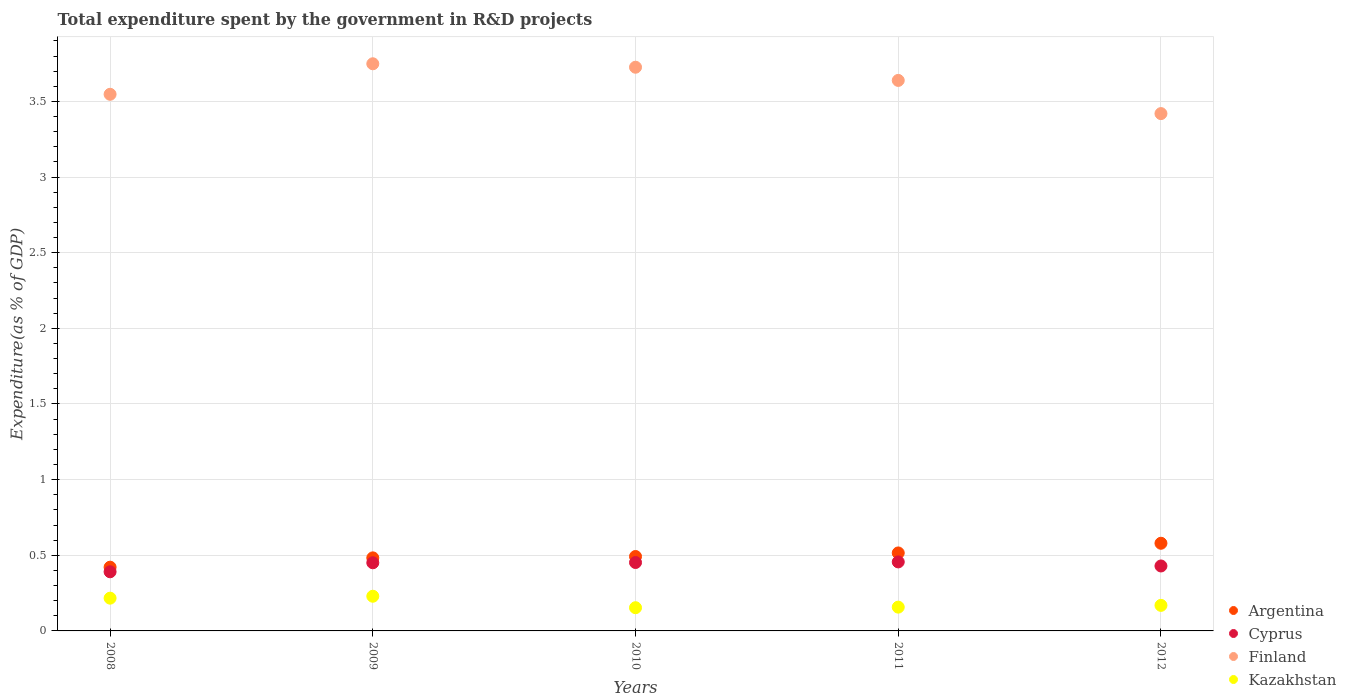Is the number of dotlines equal to the number of legend labels?
Your response must be concise. Yes. What is the total expenditure spent by the government in R&D projects in Cyprus in 2010?
Give a very brief answer. 0.45. Across all years, what is the maximum total expenditure spent by the government in R&D projects in Argentina?
Your response must be concise. 0.58. Across all years, what is the minimum total expenditure spent by the government in R&D projects in Kazakhstan?
Offer a terse response. 0.15. In which year was the total expenditure spent by the government in R&D projects in Argentina maximum?
Ensure brevity in your answer.  2012. What is the total total expenditure spent by the government in R&D projects in Kazakhstan in the graph?
Keep it short and to the point. 0.93. What is the difference between the total expenditure spent by the government in R&D projects in Kazakhstan in 2010 and that in 2011?
Offer a very short reply. -0. What is the difference between the total expenditure spent by the government in R&D projects in Argentina in 2008 and the total expenditure spent by the government in R&D projects in Cyprus in 2012?
Offer a very short reply. -0.01. What is the average total expenditure spent by the government in R&D projects in Argentina per year?
Keep it short and to the point. 0.5. In the year 2008, what is the difference between the total expenditure spent by the government in R&D projects in Argentina and total expenditure spent by the government in R&D projects in Cyprus?
Offer a terse response. 0.03. What is the ratio of the total expenditure spent by the government in R&D projects in Finland in 2008 to that in 2011?
Provide a short and direct response. 0.97. Is the total expenditure spent by the government in R&D projects in Argentina in 2011 less than that in 2012?
Your answer should be very brief. Yes. What is the difference between the highest and the second highest total expenditure spent by the government in R&D projects in Cyprus?
Keep it short and to the point. 0. What is the difference between the highest and the lowest total expenditure spent by the government in R&D projects in Argentina?
Your answer should be compact. 0.16. In how many years, is the total expenditure spent by the government in R&D projects in Argentina greater than the average total expenditure spent by the government in R&D projects in Argentina taken over all years?
Your response must be concise. 2. Is the total expenditure spent by the government in R&D projects in Kazakhstan strictly greater than the total expenditure spent by the government in R&D projects in Cyprus over the years?
Provide a short and direct response. No. Is the total expenditure spent by the government in R&D projects in Cyprus strictly less than the total expenditure spent by the government in R&D projects in Finland over the years?
Keep it short and to the point. Yes. How many years are there in the graph?
Offer a very short reply. 5. Are the values on the major ticks of Y-axis written in scientific E-notation?
Your response must be concise. No. Does the graph contain any zero values?
Make the answer very short. No. Does the graph contain grids?
Offer a terse response. Yes. What is the title of the graph?
Your answer should be compact. Total expenditure spent by the government in R&D projects. Does "United Arab Emirates" appear as one of the legend labels in the graph?
Keep it short and to the point. No. What is the label or title of the X-axis?
Give a very brief answer. Years. What is the label or title of the Y-axis?
Make the answer very short. Expenditure(as % of GDP). What is the Expenditure(as % of GDP) in Argentina in 2008?
Provide a succinct answer. 0.42. What is the Expenditure(as % of GDP) of Cyprus in 2008?
Keep it short and to the point. 0.39. What is the Expenditure(as % of GDP) of Finland in 2008?
Your answer should be compact. 3.55. What is the Expenditure(as % of GDP) of Kazakhstan in 2008?
Make the answer very short. 0.22. What is the Expenditure(as % of GDP) of Argentina in 2009?
Provide a short and direct response. 0.48. What is the Expenditure(as % of GDP) in Cyprus in 2009?
Your response must be concise. 0.45. What is the Expenditure(as % of GDP) in Finland in 2009?
Your response must be concise. 3.75. What is the Expenditure(as % of GDP) of Kazakhstan in 2009?
Provide a short and direct response. 0.23. What is the Expenditure(as % of GDP) in Argentina in 2010?
Your response must be concise. 0.49. What is the Expenditure(as % of GDP) of Cyprus in 2010?
Offer a very short reply. 0.45. What is the Expenditure(as % of GDP) of Finland in 2010?
Keep it short and to the point. 3.73. What is the Expenditure(as % of GDP) in Kazakhstan in 2010?
Give a very brief answer. 0.15. What is the Expenditure(as % of GDP) in Argentina in 2011?
Provide a short and direct response. 0.52. What is the Expenditure(as % of GDP) of Cyprus in 2011?
Your answer should be compact. 0.46. What is the Expenditure(as % of GDP) of Finland in 2011?
Ensure brevity in your answer.  3.64. What is the Expenditure(as % of GDP) in Kazakhstan in 2011?
Provide a succinct answer. 0.16. What is the Expenditure(as % of GDP) in Argentina in 2012?
Your answer should be compact. 0.58. What is the Expenditure(as % of GDP) in Cyprus in 2012?
Provide a succinct answer. 0.43. What is the Expenditure(as % of GDP) of Finland in 2012?
Offer a terse response. 3.42. What is the Expenditure(as % of GDP) in Kazakhstan in 2012?
Provide a short and direct response. 0.17. Across all years, what is the maximum Expenditure(as % of GDP) in Argentina?
Your answer should be very brief. 0.58. Across all years, what is the maximum Expenditure(as % of GDP) of Cyprus?
Offer a terse response. 0.46. Across all years, what is the maximum Expenditure(as % of GDP) of Finland?
Provide a short and direct response. 3.75. Across all years, what is the maximum Expenditure(as % of GDP) in Kazakhstan?
Offer a terse response. 0.23. Across all years, what is the minimum Expenditure(as % of GDP) in Argentina?
Make the answer very short. 0.42. Across all years, what is the minimum Expenditure(as % of GDP) in Cyprus?
Provide a short and direct response. 0.39. Across all years, what is the minimum Expenditure(as % of GDP) of Finland?
Keep it short and to the point. 3.42. Across all years, what is the minimum Expenditure(as % of GDP) in Kazakhstan?
Offer a very short reply. 0.15. What is the total Expenditure(as % of GDP) of Argentina in the graph?
Make the answer very short. 2.49. What is the total Expenditure(as % of GDP) in Cyprus in the graph?
Your answer should be compact. 2.18. What is the total Expenditure(as % of GDP) in Finland in the graph?
Offer a terse response. 18.08. What is the total Expenditure(as % of GDP) in Kazakhstan in the graph?
Provide a short and direct response. 0.93. What is the difference between the Expenditure(as % of GDP) in Argentina in 2008 and that in 2009?
Ensure brevity in your answer.  -0.06. What is the difference between the Expenditure(as % of GDP) of Cyprus in 2008 and that in 2009?
Give a very brief answer. -0.06. What is the difference between the Expenditure(as % of GDP) in Finland in 2008 and that in 2009?
Offer a terse response. -0.2. What is the difference between the Expenditure(as % of GDP) in Kazakhstan in 2008 and that in 2009?
Your answer should be compact. -0.01. What is the difference between the Expenditure(as % of GDP) of Argentina in 2008 and that in 2010?
Offer a very short reply. -0.07. What is the difference between the Expenditure(as % of GDP) of Cyprus in 2008 and that in 2010?
Keep it short and to the point. -0.06. What is the difference between the Expenditure(as % of GDP) in Finland in 2008 and that in 2010?
Your answer should be compact. -0.18. What is the difference between the Expenditure(as % of GDP) in Kazakhstan in 2008 and that in 2010?
Your answer should be compact. 0.06. What is the difference between the Expenditure(as % of GDP) in Argentina in 2008 and that in 2011?
Provide a short and direct response. -0.09. What is the difference between the Expenditure(as % of GDP) of Cyprus in 2008 and that in 2011?
Provide a succinct answer. -0.07. What is the difference between the Expenditure(as % of GDP) of Finland in 2008 and that in 2011?
Keep it short and to the point. -0.09. What is the difference between the Expenditure(as % of GDP) in Kazakhstan in 2008 and that in 2011?
Your answer should be compact. 0.06. What is the difference between the Expenditure(as % of GDP) of Argentina in 2008 and that in 2012?
Offer a very short reply. -0.16. What is the difference between the Expenditure(as % of GDP) of Cyprus in 2008 and that in 2012?
Offer a very short reply. -0.04. What is the difference between the Expenditure(as % of GDP) of Finland in 2008 and that in 2012?
Make the answer very short. 0.13. What is the difference between the Expenditure(as % of GDP) of Kazakhstan in 2008 and that in 2012?
Give a very brief answer. 0.05. What is the difference between the Expenditure(as % of GDP) of Argentina in 2009 and that in 2010?
Offer a very short reply. -0.01. What is the difference between the Expenditure(as % of GDP) in Cyprus in 2009 and that in 2010?
Ensure brevity in your answer.  -0. What is the difference between the Expenditure(as % of GDP) in Finland in 2009 and that in 2010?
Keep it short and to the point. 0.02. What is the difference between the Expenditure(as % of GDP) of Kazakhstan in 2009 and that in 2010?
Your answer should be very brief. 0.08. What is the difference between the Expenditure(as % of GDP) in Argentina in 2009 and that in 2011?
Ensure brevity in your answer.  -0.03. What is the difference between the Expenditure(as % of GDP) in Cyprus in 2009 and that in 2011?
Your answer should be very brief. -0.01. What is the difference between the Expenditure(as % of GDP) of Finland in 2009 and that in 2011?
Provide a short and direct response. 0.11. What is the difference between the Expenditure(as % of GDP) in Kazakhstan in 2009 and that in 2011?
Keep it short and to the point. 0.07. What is the difference between the Expenditure(as % of GDP) of Argentina in 2009 and that in 2012?
Your answer should be compact. -0.1. What is the difference between the Expenditure(as % of GDP) in Cyprus in 2009 and that in 2012?
Keep it short and to the point. 0.02. What is the difference between the Expenditure(as % of GDP) of Finland in 2009 and that in 2012?
Make the answer very short. 0.33. What is the difference between the Expenditure(as % of GDP) in Kazakhstan in 2009 and that in 2012?
Provide a succinct answer. 0.06. What is the difference between the Expenditure(as % of GDP) of Argentina in 2010 and that in 2011?
Offer a terse response. -0.02. What is the difference between the Expenditure(as % of GDP) of Cyprus in 2010 and that in 2011?
Your answer should be very brief. -0. What is the difference between the Expenditure(as % of GDP) of Finland in 2010 and that in 2011?
Provide a succinct answer. 0.09. What is the difference between the Expenditure(as % of GDP) of Kazakhstan in 2010 and that in 2011?
Your answer should be compact. -0. What is the difference between the Expenditure(as % of GDP) in Argentina in 2010 and that in 2012?
Provide a short and direct response. -0.09. What is the difference between the Expenditure(as % of GDP) in Cyprus in 2010 and that in 2012?
Offer a very short reply. 0.02. What is the difference between the Expenditure(as % of GDP) of Finland in 2010 and that in 2012?
Your answer should be very brief. 0.31. What is the difference between the Expenditure(as % of GDP) of Kazakhstan in 2010 and that in 2012?
Keep it short and to the point. -0.02. What is the difference between the Expenditure(as % of GDP) in Argentina in 2011 and that in 2012?
Ensure brevity in your answer.  -0.06. What is the difference between the Expenditure(as % of GDP) of Cyprus in 2011 and that in 2012?
Your answer should be very brief. 0.03. What is the difference between the Expenditure(as % of GDP) of Finland in 2011 and that in 2012?
Make the answer very short. 0.22. What is the difference between the Expenditure(as % of GDP) of Kazakhstan in 2011 and that in 2012?
Provide a succinct answer. -0.01. What is the difference between the Expenditure(as % of GDP) of Argentina in 2008 and the Expenditure(as % of GDP) of Cyprus in 2009?
Your answer should be compact. -0.03. What is the difference between the Expenditure(as % of GDP) of Argentina in 2008 and the Expenditure(as % of GDP) of Finland in 2009?
Your response must be concise. -3.33. What is the difference between the Expenditure(as % of GDP) in Argentina in 2008 and the Expenditure(as % of GDP) in Kazakhstan in 2009?
Give a very brief answer. 0.19. What is the difference between the Expenditure(as % of GDP) of Cyprus in 2008 and the Expenditure(as % of GDP) of Finland in 2009?
Offer a very short reply. -3.36. What is the difference between the Expenditure(as % of GDP) of Cyprus in 2008 and the Expenditure(as % of GDP) of Kazakhstan in 2009?
Give a very brief answer. 0.16. What is the difference between the Expenditure(as % of GDP) in Finland in 2008 and the Expenditure(as % of GDP) in Kazakhstan in 2009?
Your answer should be compact. 3.32. What is the difference between the Expenditure(as % of GDP) in Argentina in 2008 and the Expenditure(as % of GDP) in Cyprus in 2010?
Provide a short and direct response. -0.03. What is the difference between the Expenditure(as % of GDP) in Argentina in 2008 and the Expenditure(as % of GDP) in Finland in 2010?
Your response must be concise. -3.3. What is the difference between the Expenditure(as % of GDP) in Argentina in 2008 and the Expenditure(as % of GDP) in Kazakhstan in 2010?
Keep it short and to the point. 0.27. What is the difference between the Expenditure(as % of GDP) in Cyprus in 2008 and the Expenditure(as % of GDP) in Finland in 2010?
Your answer should be compact. -3.34. What is the difference between the Expenditure(as % of GDP) in Cyprus in 2008 and the Expenditure(as % of GDP) in Kazakhstan in 2010?
Your response must be concise. 0.24. What is the difference between the Expenditure(as % of GDP) in Finland in 2008 and the Expenditure(as % of GDP) in Kazakhstan in 2010?
Offer a very short reply. 3.39. What is the difference between the Expenditure(as % of GDP) in Argentina in 2008 and the Expenditure(as % of GDP) in Cyprus in 2011?
Your answer should be very brief. -0.03. What is the difference between the Expenditure(as % of GDP) of Argentina in 2008 and the Expenditure(as % of GDP) of Finland in 2011?
Your answer should be very brief. -3.22. What is the difference between the Expenditure(as % of GDP) in Argentina in 2008 and the Expenditure(as % of GDP) in Kazakhstan in 2011?
Provide a succinct answer. 0.26. What is the difference between the Expenditure(as % of GDP) in Cyprus in 2008 and the Expenditure(as % of GDP) in Finland in 2011?
Your response must be concise. -3.25. What is the difference between the Expenditure(as % of GDP) in Cyprus in 2008 and the Expenditure(as % of GDP) in Kazakhstan in 2011?
Your response must be concise. 0.23. What is the difference between the Expenditure(as % of GDP) of Finland in 2008 and the Expenditure(as % of GDP) of Kazakhstan in 2011?
Your answer should be compact. 3.39. What is the difference between the Expenditure(as % of GDP) of Argentina in 2008 and the Expenditure(as % of GDP) of Cyprus in 2012?
Offer a terse response. -0.01. What is the difference between the Expenditure(as % of GDP) in Argentina in 2008 and the Expenditure(as % of GDP) in Finland in 2012?
Your response must be concise. -3. What is the difference between the Expenditure(as % of GDP) of Argentina in 2008 and the Expenditure(as % of GDP) of Kazakhstan in 2012?
Your answer should be compact. 0.25. What is the difference between the Expenditure(as % of GDP) of Cyprus in 2008 and the Expenditure(as % of GDP) of Finland in 2012?
Your answer should be very brief. -3.03. What is the difference between the Expenditure(as % of GDP) of Cyprus in 2008 and the Expenditure(as % of GDP) of Kazakhstan in 2012?
Your answer should be compact. 0.22. What is the difference between the Expenditure(as % of GDP) in Finland in 2008 and the Expenditure(as % of GDP) in Kazakhstan in 2012?
Your answer should be very brief. 3.38. What is the difference between the Expenditure(as % of GDP) in Argentina in 2009 and the Expenditure(as % of GDP) in Cyprus in 2010?
Provide a short and direct response. 0.03. What is the difference between the Expenditure(as % of GDP) of Argentina in 2009 and the Expenditure(as % of GDP) of Finland in 2010?
Offer a terse response. -3.24. What is the difference between the Expenditure(as % of GDP) of Argentina in 2009 and the Expenditure(as % of GDP) of Kazakhstan in 2010?
Your response must be concise. 0.33. What is the difference between the Expenditure(as % of GDP) in Cyprus in 2009 and the Expenditure(as % of GDP) in Finland in 2010?
Your response must be concise. -3.28. What is the difference between the Expenditure(as % of GDP) of Cyprus in 2009 and the Expenditure(as % of GDP) of Kazakhstan in 2010?
Your response must be concise. 0.3. What is the difference between the Expenditure(as % of GDP) of Finland in 2009 and the Expenditure(as % of GDP) of Kazakhstan in 2010?
Keep it short and to the point. 3.6. What is the difference between the Expenditure(as % of GDP) in Argentina in 2009 and the Expenditure(as % of GDP) in Cyprus in 2011?
Your answer should be very brief. 0.03. What is the difference between the Expenditure(as % of GDP) in Argentina in 2009 and the Expenditure(as % of GDP) in Finland in 2011?
Your answer should be compact. -3.16. What is the difference between the Expenditure(as % of GDP) of Argentina in 2009 and the Expenditure(as % of GDP) of Kazakhstan in 2011?
Provide a short and direct response. 0.33. What is the difference between the Expenditure(as % of GDP) of Cyprus in 2009 and the Expenditure(as % of GDP) of Finland in 2011?
Offer a very short reply. -3.19. What is the difference between the Expenditure(as % of GDP) of Cyprus in 2009 and the Expenditure(as % of GDP) of Kazakhstan in 2011?
Provide a succinct answer. 0.29. What is the difference between the Expenditure(as % of GDP) of Finland in 2009 and the Expenditure(as % of GDP) of Kazakhstan in 2011?
Ensure brevity in your answer.  3.59. What is the difference between the Expenditure(as % of GDP) in Argentina in 2009 and the Expenditure(as % of GDP) in Cyprus in 2012?
Keep it short and to the point. 0.05. What is the difference between the Expenditure(as % of GDP) of Argentina in 2009 and the Expenditure(as % of GDP) of Finland in 2012?
Offer a terse response. -2.94. What is the difference between the Expenditure(as % of GDP) in Argentina in 2009 and the Expenditure(as % of GDP) in Kazakhstan in 2012?
Provide a short and direct response. 0.31. What is the difference between the Expenditure(as % of GDP) in Cyprus in 2009 and the Expenditure(as % of GDP) in Finland in 2012?
Make the answer very short. -2.97. What is the difference between the Expenditure(as % of GDP) of Cyprus in 2009 and the Expenditure(as % of GDP) of Kazakhstan in 2012?
Offer a very short reply. 0.28. What is the difference between the Expenditure(as % of GDP) of Finland in 2009 and the Expenditure(as % of GDP) of Kazakhstan in 2012?
Provide a succinct answer. 3.58. What is the difference between the Expenditure(as % of GDP) in Argentina in 2010 and the Expenditure(as % of GDP) in Cyprus in 2011?
Offer a terse response. 0.04. What is the difference between the Expenditure(as % of GDP) of Argentina in 2010 and the Expenditure(as % of GDP) of Finland in 2011?
Keep it short and to the point. -3.15. What is the difference between the Expenditure(as % of GDP) in Argentina in 2010 and the Expenditure(as % of GDP) in Kazakhstan in 2011?
Keep it short and to the point. 0.33. What is the difference between the Expenditure(as % of GDP) of Cyprus in 2010 and the Expenditure(as % of GDP) of Finland in 2011?
Your answer should be very brief. -3.19. What is the difference between the Expenditure(as % of GDP) of Cyprus in 2010 and the Expenditure(as % of GDP) of Kazakhstan in 2011?
Offer a terse response. 0.29. What is the difference between the Expenditure(as % of GDP) in Finland in 2010 and the Expenditure(as % of GDP) in Kazakhstan in 2011?
Give a very brief answer. 3.57. What is the difference between the Expenditure(as % of GDP) in Argentina in 2010 and the Expenditure(as % of GDP) in Cyprus in 2012?
Keep it short and to the point. 0.06. What is the difference between the Expenditure(as % of GDP) in Argentina in 2010 and the Expenditure(as % of GDP) in Finland in 2012?
Make the answer very short. -2.93. What is the difference between the Expenditure(as % of GDP) of Argentina in 2010 and the Expenditure(as % of GDP) of Kazakhstan in 2012?
Provide a succinct answer. 0.32. What is the difference between the Expenditure(as % of GDP) of Cyprus in 2010 and the Expenditure(as % of GDP) of Finland in 2012?
Provide a succinct answer. -2.97. What is the difference between the Expenditure(as % of GDP) of Cyprus in 2010 and the Expenditure(as % of GDP) of Kazakhstan in 2012?
Offer a terse response. 0.28. What is the difference between the Expenditure(as % of GDP) in Finland in 2010 and the Expenditure(as % of GDP) in Kazakhstan in 2012?
Offer a very short reply. 3.56. What is the difference between the Expenditure(as % of GDP) of Argentina in 2011 and the Expenditure(as % of GDP) of Cyprus in 2012?
Keep it short and to the point. 0.09. What is the difference between the Expenditure(as % of GDP) of Argentina in 2011 and the Expenditure(as % of GDP) of Finland in 2012?
Provide a succinct answer. -2.9. What is the difference between the Expenditure(as % of GDP) of Argentina in 2011 and the Expenditure(as % of GDP) of Kazakhstan in 2012?
Give a very brief answer. 0.35. What is the difference between the Expenditure(as % of GDP) in Cyprus in 2011 and the Expenditure(as % of GDP) in Finland in 2012?
Your response must be concise. -2.96. What is the difference between the Expenditure(as % of GDP) in Cyprus in 2011 and the Expenditure(as % of GDP) in Kazakhstan in 2012?
Provide a succinct answer. 0.29. What is the difference between the Expenditure(as % of GDP) in Finland in 2011 and the Expenditure(as % of GDP) in Kazakhstan in 2012?
Offer a very short reply. 3.47. What is the average Expenditure(as % of GDP) in Argentina per year?
Give a very brief answer. 0.5. What is the average Expenditure(as % of GDP) of Cyprus per year?
Your response must be concise. 0.44. What is the average Expenditure(as % of GDP) of Finland per year?
Offer a very short reply. 3.62. What is the average Expenditure(as % of GDP) in Kazakhstan per year?
Ensure brevity in your answer.  0.19. In the year 2008, what is the difference between the Expenditure(as % of GDP) of Argentina and Expenditure(as % of GDP) of Cyprus?
Offer a very short reply. 0.03. In the year 2008, what is the difference between the Expenditure(as % of GDP) in Argentina and Expenditure(as % of GDP) in Finland?
Ensure brevity in your answer.  -3.13. In the year 2008, what is the difference between the Expenditure(as % of GDP) in Argentina and Expenditure(as % of GDP) in Kazakhstan?
Your answer should be very brief. 0.2. In the year 2008, what is the difference between the Expenditure(as % of GDP) in Cyprus and Expenditure(as % of GDP) in Finland?
Provide a short and direct response. -3.16. In the year 2008, what is the difference between the Expenditure(as % of GDP) in Cyprus and Expenditure(as % of GDP) in Kazakhstan?
Provide a succinct answer. 0.17. In the year 2008, what is the difference between the Expenditure(as % of GDP) of Finland and Expenditure(as % of GDP) of Kazakhstan?
Your response must be concise. 3.33. In the year 2009, what is the difference between the Expenditure(as % of GDP) in Argentina and Expenditure(as % of GDP) in Cyprus?
Your answer should be very brief. 0.03. In the year 2009, what is the difference between the Expenditure(as % of GDP) in Argentina and Expenditure(as % of GDP) in Finland?
Offer a terse response. -3.27. In the year 2009, what is the difference between the Expenditure(as % of GDP) of Argentina and Expenditure(as % of GDP) of Kazakhstan?
Provide a succinct answer. 0.25. In the year 2009, what is the difference between the Expenditure(as % of GDP) of Cyprus and Expenditure(as % of GDP) of Finland?
Offer a terse response. -3.3. In the year 2009, what is the difference between the Expenditure(as % of GDP) of Cyprus and Expenditure(as % of GDP) of Kazakhstan?
Ensure brevity in your answer.  0.22. In the year 2009, what is the difference between the Expenditure(as % of GDP) of Finland and Expenditure(as % of GDP) of Kazakhstan?
Provide a short and direct response. 3.52. In the year 2010, what is the difference between the Expenditure(as % of GDP) of Argentina and Expenditure(as % of GDP) of Cyprus?
Give a very brief answer. 0.04. In the year 2010, what is the difference between the Expenditure(as % of GDP) in Argentina and Expenditure(as % of GDP) in Finland?
Your response must be concise. -3.23. In the year 2010, what is the difference between the Expenditure(as % of GDP) of Argentina and Expenditure(as % of GDP) of Kazakhstan?
Keep it short and to the point. 0.34. In the year 2010, what is the difference between the Expenditure(as % of GDP) in Cyprus and Expenditure(as % of GDP) in Finland?
Keep it short and to the point. -3.27. In the year 2010, what is the difference between the Expenditure(as % of GDP) of Cyprus and Expenditure(as % of GDP) of Kazakhstan?
Provide a succinct answer. 0.3. In the year 2010, what is the difference between the Expenditure(as % of GDP) in Finland and Expenditure(as % of GDP) in Kazakhstan?
Your response must be concise. 3.57. In the year 2011, what is the difference between the Expenditure(as % of GDP) of Argentina and Expenditure(as % of GDP) of Cyprus?
Keep it short and to the point. 0.06. In the year 2011, what is the difference between the Expenditure(as % of GDP) of Argentina and Expenditure(as % of GDP) of Finland?
Your answer should be compact. -3.12. In the year 2011, what is the difference between the Expenditure(as % of GDP) of Argentina and Expenditure(as % of GDP) of Kazakhstan?
Keep it short and to the point. 0.36. In the year 2011, what is the difference between the Expenditure(as % of GDP) of Cyprus and Expenditure(as % of GDP) of Finland?
Offer a terse response. -3.18. In the year 2011, what is the difference between the Expenditure(as % of GDP) of Cyprus and Expenditure(as % of GDP) of Kazakhstan?
Make the answer very short. 0.3. In the year 2011, what is the difference between the Expenditure(as % of GDP) of Finland and Expenditure(as % of GDP) of Kazakhstan?
Make the answer very short. 3.48. In the year 2012, what is the difference between the Expenditure(as % of GDP) in Argentina and Expenditure(as % of GDP) in Cyprus?
Your answer should be very brief. 0.15. In the year 2012, what is the difference between the Expenditure(as % of GDP) of Argentina and Expenditure(as % of GDP) of Finland?
Give a very brief answer. -2.84. In the year 2012, what is the difference between the Expenditure(as % of GDP) in Argentina and Expenditure(as % of GDP) in Kazakhstan?
Offer a very short reply. 0.41. In the year 2012, what is the difference between the Expenditure(as % of GDP) of Cyprus and Expenditure(as % of GDP) of Finland?
Your answer should be very brief. -2.99. In the year 2012, what is the difference between the Expenditure(as % of GDP) in Cyprus and Expenditure(as % of GDP) in Kazakhstan?
Provide a short and direct response. 0.26. In the year 2012, what is the difference between the Expenditure(as % of GDP) in Finland and Expenditure(as % of GDP) in Kazakhstan?
Offer a terse response. 3.25. What is the ratio of the Expenditure(as % of GDP) in Argentina in 2008 to that in 2009?
Your answer should be compact. 0.87. What is the ratio of the Expenditure(as % of GDP) of Cyprus in 2008 to that in 2009?
Provide a succinct answer. 0.87. What is the ratio of the Expenditure(as % of GDP) in Finland in 2008 to that in 2009?
Make the answer very short. 0.95. What is the ratio of the Expenditure(as % of GDP) in Kazakhstan in 2008 to that in 2009?
Make the answer very short. 0.94. What is the ratio of the Expenditure(as % of GDP) of Argentina in 2008 to that in 2010?
Your answer should be compact. 0.86. What is the ratio of the Expenditure(as % of GDP) in Cyprus in 2008 to that in 2010?
Offer a very short reply. 0.86. What is the ratio of the Expenditure(as % of GDP) of Kazakhstan in 2008 to that in 2010?
Offer a terse response. 1.41. What is the ratio of the Expenditure(as % of GDP) of Argentina in 2008 to that in 2011?
Provide a short and direct response. 0.82. What is the ratio of the Expenditure(as % of GDP) of Cyprus in 2008 to that in 2011?
Provide a short and direct response. 0.86. What is the ratio of the Expenditure(as % of GDP) of Finland in 2008 to that in 2011?
Offer a terse response. 0.97. What is the ratio of the Expenditure(as % of GDP) of Kazakhstan in 2008 to that in 2011?
Your answer should be very brief. 1.38. What is the ratio of the Expenditure(as % of GDP) of Argentina in 2008 to that in 2012?
Your answer should be very brief. 0.73. What is the ratio of the Expenditure(as % of GDP) in Cyprus in 2008 to that in 2012?
Ensure brevity in your answer.  0.91. What is the ratio of the Expenditure(as % of GDP) in Finland in 2008 to that in 2012?
Give a very brief answer. 1.04. What is the ratio of the Expenditure(as % of GDP) in Kazakhstan in 2008 to that in 2012?
Offer a very short reply. 1.28. What is the ratio of the Expenditure(as % of GDP) of Argentina in 2009 to that in 2010?
Offer a terse response. 0.98. What is the ratio of the Expenditure(as % of GDP) of Kazakhstan in 2009 to that in 2010?
Keep it short and to the point. 1.49. What is the ratio of the Expenditure(as % of GDP) of Argentina in 2009 to that in 2011?
Your answer should be very brief. 0.94. What is the ratio of the Expenditure(as % of GDP) of Cyprus in 2009 to that in 2011?
Keep it short and to the point. 0.99. What is the ratio of the Expenditure(as % of GDP) of Finland in 2009 to that in 2011?
Give a very brief answer. 1.03. What is the ratio of the Expenditure(as % of GDP) in Kazakhstan in 2009 to that in 2011?
Ensure brevity in your answer.  1.46. What is the ratio of the Expenditure(as % of GDP) of Argentina in 2009 to that in 2012?
Give a very brief answer. 0.83. What is the ratio of the Expenditure(as % of GDP) in Cyprus in 2009 to that in 2012?
Ensure brevity in your answer.  1.05. What is the ratio of the Expenditure(as % of GDP) of Finland in 2009 to that in 2012?
Provide a succinct answer. 1.1. What is the ratio of the Expenditure(as % of GDP) of Kazakhstan in 2009 to that in 2012?
Provide a succinct answer. 1.36. What is the ratio of the Expenditure(as % of GDP) in Argentina in 2010 to that in 2011?
Ensure brevity in your answer.  0.95. What is the ratio of the Expenditure(as % of GDP) of Cyprus in 2010 to that in 2011?
Make the answer very short. 0.99. What is the ratio of the Expenditure(as % of GDP) in Finland in 2010 to that in 2011?
Offer a very short reply. 1.02. What is the ratio of the Expenditure(as % of GDP) in Kazakhstan in 2010 to that in 2011?
Give a very brief answer. 0.98. What is the ratio of the Expenditure(as % of GDP) of Argentina in 2010 to that in 2012?
Provide a short and direct response. 0.85. What is the ratio of the Expenditure(as % of GDP) of Cyprus in 2010 to that in 2012?
Ensure brevity in your answer.  1.05. What is the ratio of the Expenditure(as % of GDP) in Finland in 2010 to that in 2012?
Your response must be concise. 1.09. What is the ratio of the Expenditure(as % of GDP) in Kazakhstan in 2010 to that in 2012?
Offer a terse response. 0.91. What is the ratio of the Expenditure(as % of GDP) in Argentina in 2011 to that in 2012?
Keep it short and to the point. 0.89. What is the ratio of the Expenditure(as % of GDP) of Cyprus in 2011 to that in 2012?
Keep it short and to the point. 1.06. What is the ratio of the Expenditure(as % of GDP) in Finland in 2011 to that in 2012?
Your response must be concise. 1.06. What is the difference between the highest and the second highest Expenditure(as % of GDP) of Argentina?
Keep it short and to the point. 0.06. What is the difference between the highest and the second highest Expenditure(as % of GDP) of Cyprus?
Your answer should be compact. 0. What is the difference between the highest and the second highest Expenditure(as % of GDP) in Finland?
Your answer should be compact. 0.02. What is the difference between the highest and the second highest Expenditure(as % of GDP) in Kazakhstan?
Keep it short and to the point. 0.01. What is the difference between the highest and the lowest Expenditure(as % of GDP) in Argentina?
Your answer should be compact. 0.16. What is the difference between the highest and the lowest Expenditure(as % of GDP) in Cyprus?
Offer a very short reply. 0.07. What is the difference between the highest and the lowest Expenditure(as % of GDP) in Finland?
Keep it short and to the point. 0.33. What is the difference between the highest and the lowest Expenditure(as % of GDP) of Kazakhstan?
Your response must be concise. 0.08. 